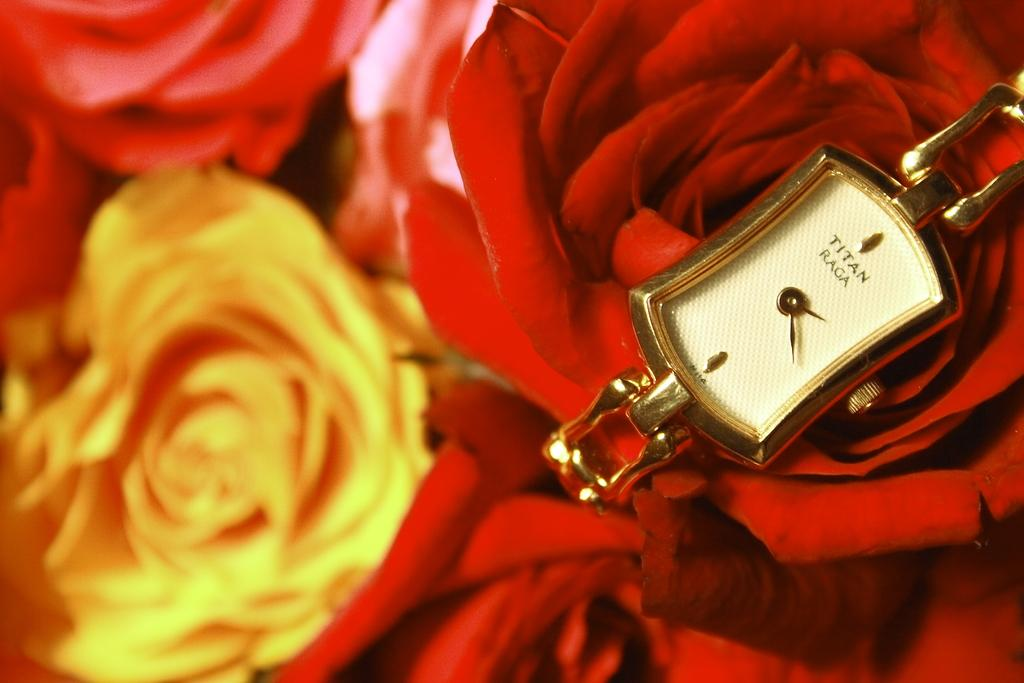<image>
Render a clear and concise summary of the photo. Face of a watch which says "TITAN" on the front. 